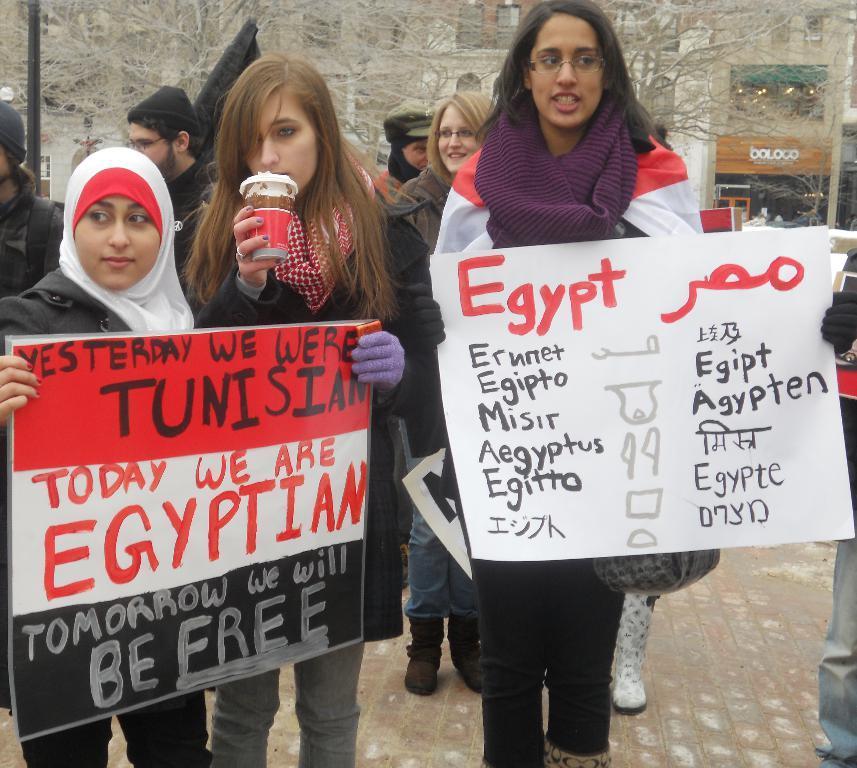How would you summarize this image in a sentence or two? In the foreground of the image there are people holding papers with some text on them. In the background of the image there are people standing. There is wall. There are trees. At the bottom of the image there is floor. 